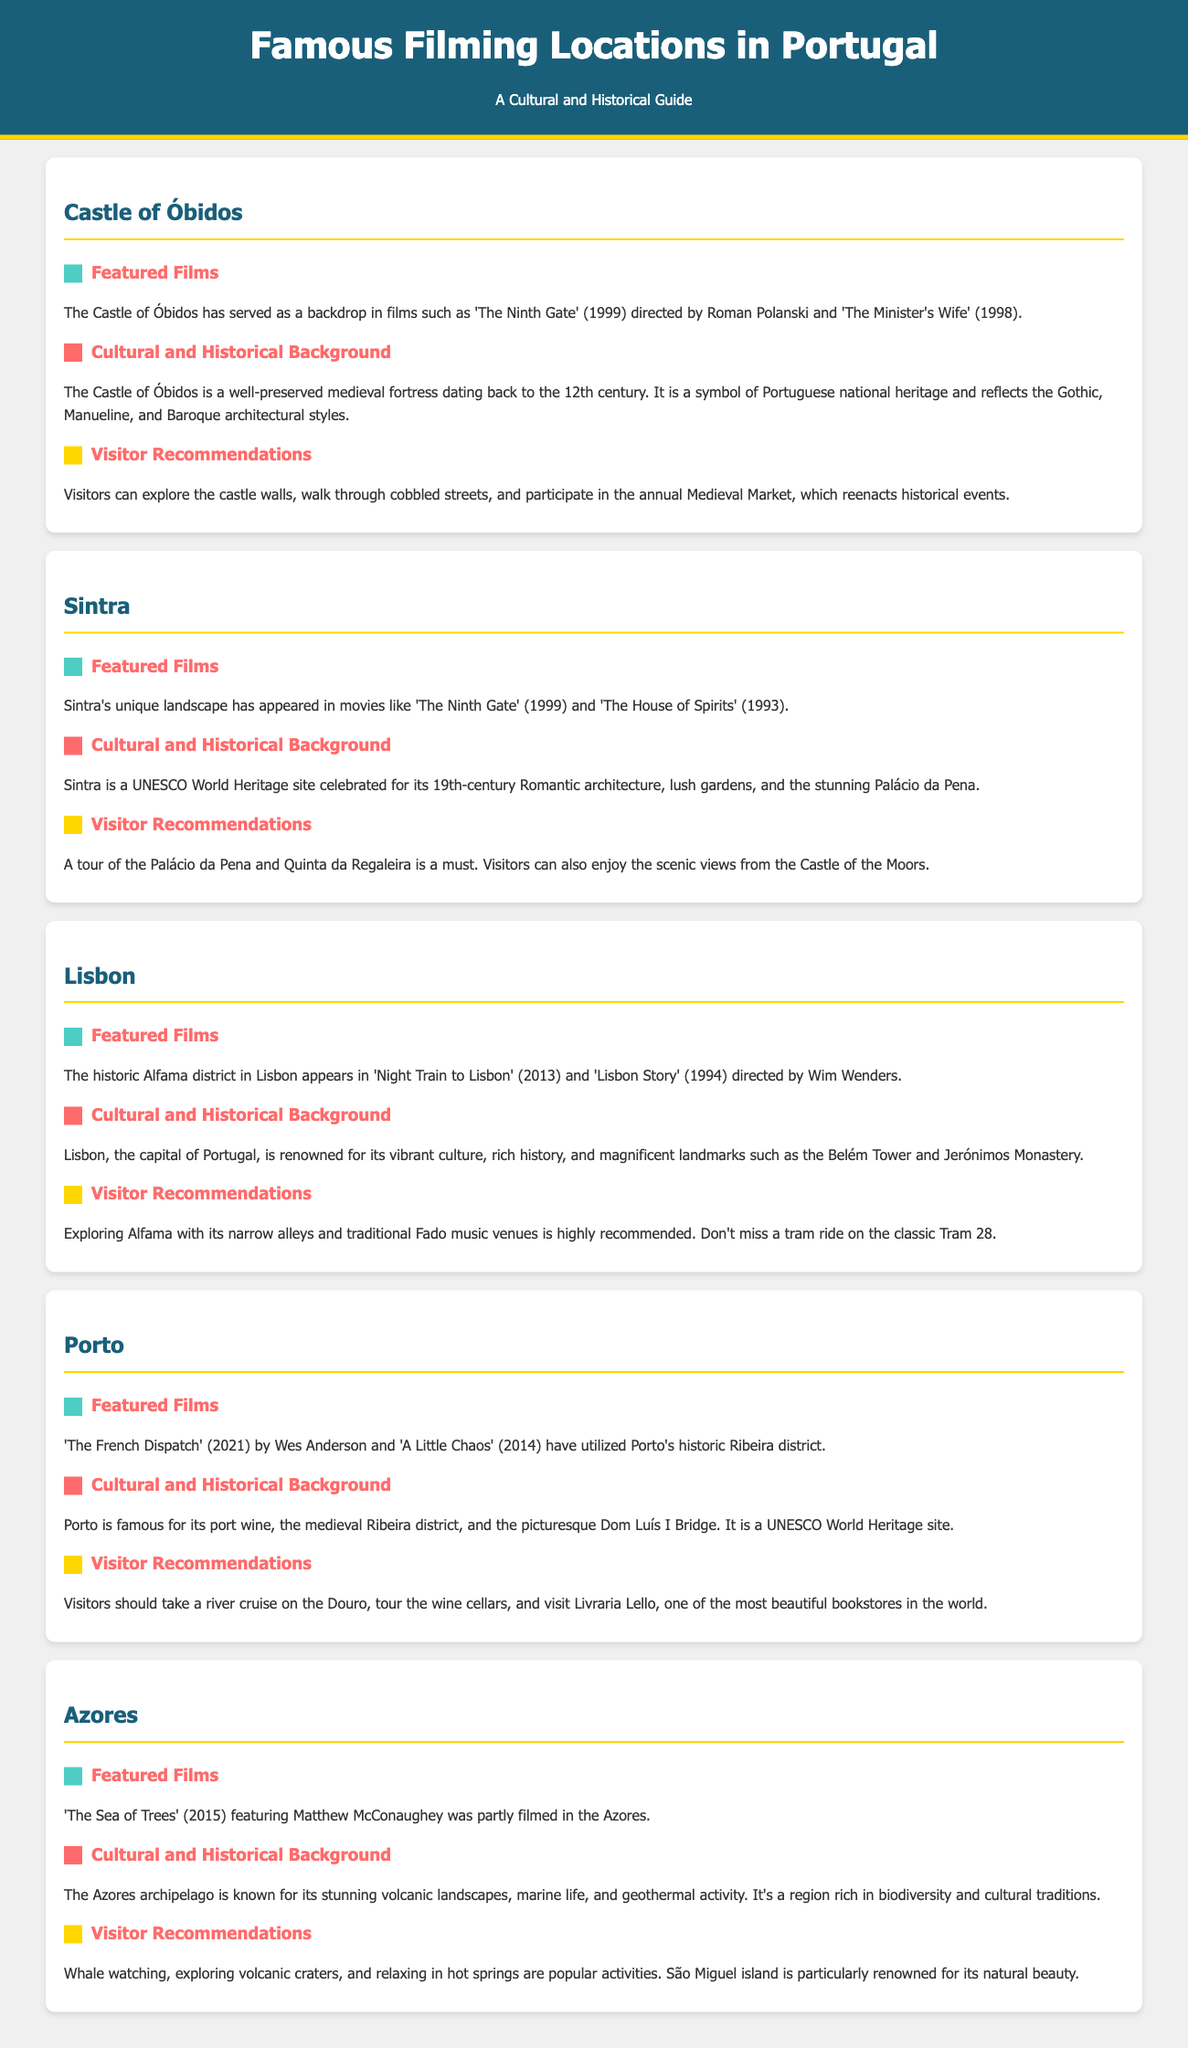What films were shot at the Castle of Óbidos? The document states that the Castle of Óbidos has served as a backdrop in films such as 'The Ninth Gate' (1999) and 'The Minister's Wife' (1998).
Answer: 'The Ninth Gate' and 'The Minister's Wife' What architectural styles are reflected in the Castle of Óbidos? The cultural and historical background mentions that the castle reflects Gothic, Manueline, and Baroque architectural styles.
Answer: Gothic, Manueline, and Baroque Which UNESCO World Heritage site includes the Palácio da Pena? The document describes Sintra as a UNESCO World Heritage site celebrated for its architecture and gardens, including the Palácio da Pena.
Answer: Sintra What is a recommended activity in Porto? According to the visitor recommendations, a suggested activity is to take a river cruise on the Douro.
Answer: River cruise on the Douro Who directed 'Night Train to Lisbon'? The film 'Night Train to Lisbon' is listed under Lisbon's featured films, directed by Bille August.
Answer: Bille August What type of landscape is famous in the Azores? The history description mentions that the Azores are known for stunning volcanic landscapes.
Answer: Volcanic landscapes Which movie featuring Matthew McConaughey was filmed in the Azores? The document specifically states that 'The Sea of Trees' (2015) was partly filmed in the Azores.
Answer: 'The Sea of Trees' What is a popular cultural event at the Castle of Óbidos? The visitor recommendations indicate that the annual Medieval Market reenacts historical events.
Answer: Medieval Market 